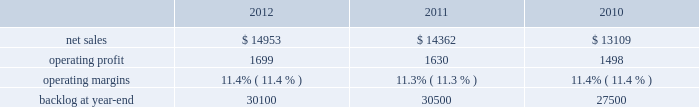Aeronautics business segment 2019s results of operations discussion .
The increase in our consolidated net adjustments for 2011 as compared to 2010 primarily was due to an increase in profit booking rate adjustments at our is&gs and aeronautics business segments .
Aeronautics our aeronautics business segment is engaged in the research , design , development , manufacture , integration , sustainment , support , and upgrade of advanced military aircraft , including combat and air mobility aircraft , unmanned air vehicles , and related technologies .
Aeronautics 2019 major programs include the f-35 lightning ii joint strike fighter , f-22 raptor , f-16 fighting falcon , c-130 hercules , and the c-5m super galaxy .
Aeronautics 2019 operating results included the following ( in millions ) : .
2012 compared to 2011 aeronautics 2019 net sales for 2012 increased $ 591 million , or 4% ( 4 % ) , compared to 2011 .
The increase was attributable to higher net sales of approximately $ 745 million from f-35 lrip contracts principally due to increased production volume ; about $ 285 million from f-16 programs primarily due to higher aircraft deliveries ( 37 f-16 aircraft delivered in 2012 compared to 22 in 2011 ) partially offset by lower volume on sustainment activities due to the completion of modification programs for certain international customers ; and approximately $ 140 million from c-5 programs due to higher aircraft deliveries ( four c-5m aircraft delivered in 2012 compared to two in 2011 ) .
Partially offsetting the increases were lower net sales of approximately $ 365 million from decreased production volume and lower risk retirements on the f-22 program as final aircraft deliveries were completed in the second quarter of 2012 ; approximately $ 110 million from the f-35 development contract primarily due to the inception-to-date effect of reducing the profit booking rate in the second quarter of 2012 and to a lesser extent lower volume ; and about $ 95 million from a decrease in volume on other sustainment activities partially offset by various other aeronautics programs due to higher volume .
Net sales for c-130 programs were comparable to 2011 as a decline in sustainment activities largely was offset by increased aircraft deliveries .
Aeronautics 2019 operating profit for 2012 increased $ 69 million , or 4% ( 4 % ) , compared to 2011 .
The increase was attributable to higher operating profit of approximately $ 105 million from c-130 programs due to an increase in risk retirements ; about $ 50 million from f-16 programs due to higher aircraft deliveries partially offset by a decline in risk retirements ; approximately $ 50 million from f-35 lrip contracts due to increased production volume and risk retirements ; and about $ 50 million from the completion of purchased intangible asset amortization on certain f-16 contracts .
Partially offsetting the increases was lower operating profit of about $ 90 million from the f-35 development contract primarily due to the inception- to-date effect of reducing the profit booking rate in the second quarter of 2012 ; approximately $ 50 million from decreased production volume and risk retirements on the f-22 program partially offset by a resolution of a contractual matter in the second quarter of 2012 ; and approximately $ 45 million primarily due to a decrease in risk retirements on other sustainment activities partially offset by various other aeronautics programs due to increased risk retirements and volume .
Operating profit for c-5 programs was comparable to 2011 .
Adjustments not related to volume , including net profit booking rate adjustments and other matters described above , were approximately $ 30 million lower for 2012 compared to 2011 .
2011 compared to 2010 aeronautics 2019 net sales for 2011 increased $ 1.3 billion , or 10% ( 10 % ) , compared to 2010 .
The growth in net sales primarily was due to higher volume of about $ 850 million for work performed on the f-35 lrip contracts as production increased ; higher volume of about $ 745 million for c-130 programs due to an increase in deliveries ( 33 c-130j aircraft delivered in 2011 compared to 25 during 2010 ) and support activities ; about $ 425 million for f-16 support activities and an increase in aircraft deliveries ( 22 f-16 aircraft delivered in 2011 compared to 20 during 2010 ) ; and approximately $ 90 million for higher volume on c-5 programs ( two c-5m aircraft delivered in 2011 compared to one during 2010 ) .
These increases partially were offset by a decline in net sales of approximately $ 675 million due to lower volume on the f-22 program and lower net sales of about $ 155 million for the f-35 development contract as development work decreased. .
What was the percent of net sales attributable to the f-35 lrip contracts included in the 2012 sales? 
Computations: (745 / 14953)
Answer: 0.04982. 